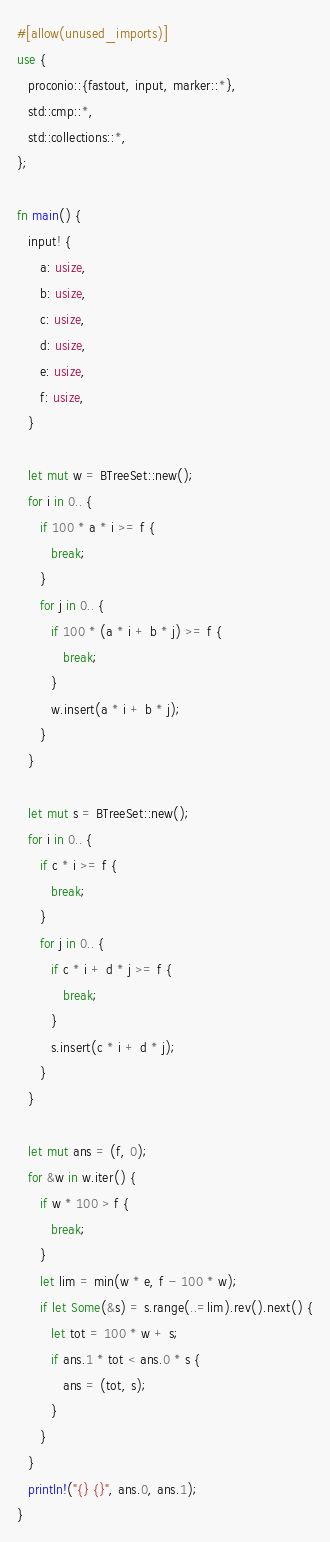<code> <loc_0><loc_0><loc_500><loc_500><_Rust_>#[allow(unused_imports)]
use {
   proconio::{fastout, input, marker::*},
   std::cmp::*,
   std::collections::*,
};

fn main() {
   input! {
      a: usize,
      b: usize,
      c: usize,
      d: usize,
      e: usize,
      f: usize,
   }

   let mut w = BTreeSet::new();
   for i in 0.. {
      if 100 * a * i >= f {
         break;
      }
      for j in 0.. {
         if 100 * (a * i + b * j) >= f {
            break;
         }
         w.insert(a * i + b * j);
      }
   }

   let mut s = BTreeSet::new();
   for i in 0.. {
      if c * i >= f {
         break;
      }
      for j in 0.. {
         if c * i + d * j >= f {
            break;
         }
         s.insert(c * i + d * j);
      }
   }

   let mut ans = (f, 0);
   for &w in w.iter() {
      if w * 100 > f {
         break;
      }
      let lim = min(w * e, f - 100 * w);
      if let Some(&s) = s.range(..=lim).rev().next() {
         let tot = 100 * w + s;
         if ans.1 * tot < ans.0 * s {
            ans = (tot, s);
         }
      }
   }
   println!("{} {}", ans.0, ans.1);
}
</code> 